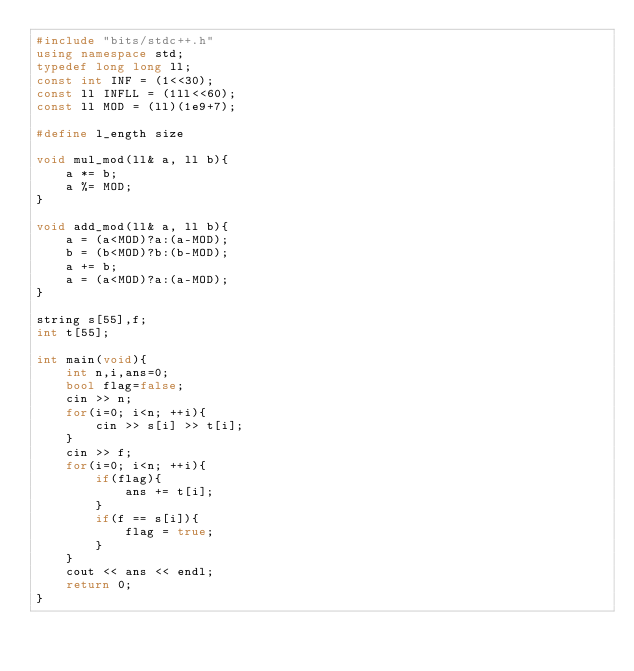Convert code to text. <code><loc_0><loc_0><loc_500><loc_500><_C++_>#include "bits/stdc++.h"
using namespace std;
typedef long long ll;
const int INF = (1<<30);
const ll INFLL = (1ll<<60);
const ll MOD = (ll)(1e9+7);

#define l_ength size

void mul_mod(ll& a, ll b){
	a *= b;
	a %= MOD;
}

void add_mod(ll& a, ll b){
	a = (a<MOD)?a:(a-MOD);
	b = (b<MOD)?b:(b-MOD);
	a += b;
	a = (a<MOD)?a:(a-MOD);
}

string s[55],f;
int t[55];

int main(void){
	int n,i,ans=0;
	bool flag=false;
	cin >> n;
	for(i=0; i<n; ++i){
		cin >> s[i] >> t[i];
	}
	cin >> f;
	for(i=0; i<n; ++i){
		if(flag){
			ans += t[i];
		}
		if(f == s[i]){
			flag = true;
		}
	}
	cout << ans << endl;
	return 0;
}
</code> 